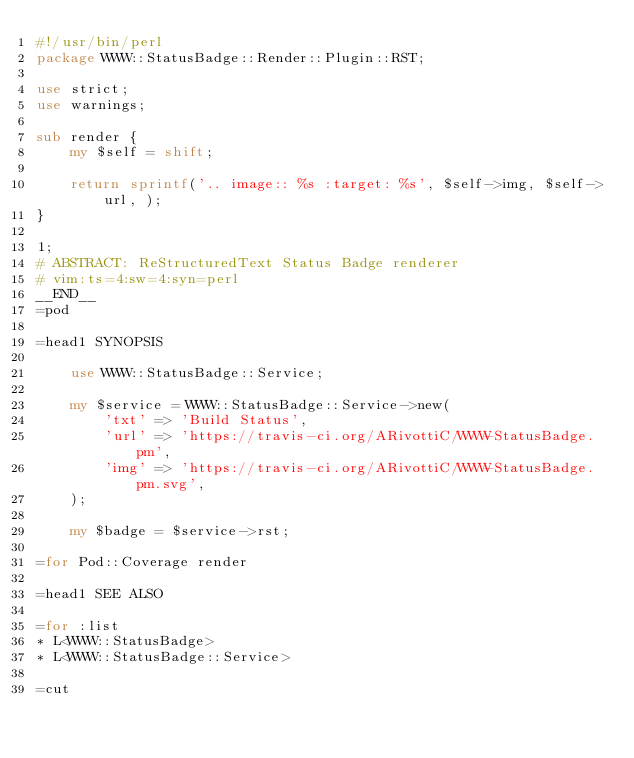Convert code to text. <code><loc_0><loc_0><loc_500><loc_500><_Perl_>#!/usr/bin/perl
package WWW::StatusBadge::Render::Plugin::RST;

use strict;
use warnings;

sub render {
    my $self = shift;

    return sprintf('.. image:: %s :target: %s', $self->img, $self->url, );
}

1;
# ABSTRACT: ReStructuredText Status Badge renderer
# vim:ts=4:sw=4:syn=perl
__END__
=pod

=head1 SYNOPSIS

    use WWW::StatusBadge::Service;

    my $service = WWW::StatusBadge::Service->new(
        'txt' => 'Build Status',
        'url' => 'https://travis-ci.org/ARivottiC/WWW-StatusBadge.pm',
        'img' => 'https://travis-ci.org/ARivottiC/WWW-StatusBadge.pm.svg',
    );

    my $badge = $service->rst;

=for Pod::Coverage render

=head1 SEE ALSO

=for :list
* L<WWW::StatusBadge>
* L<WWW::StatusBadge::Service>

=cut
</code> 